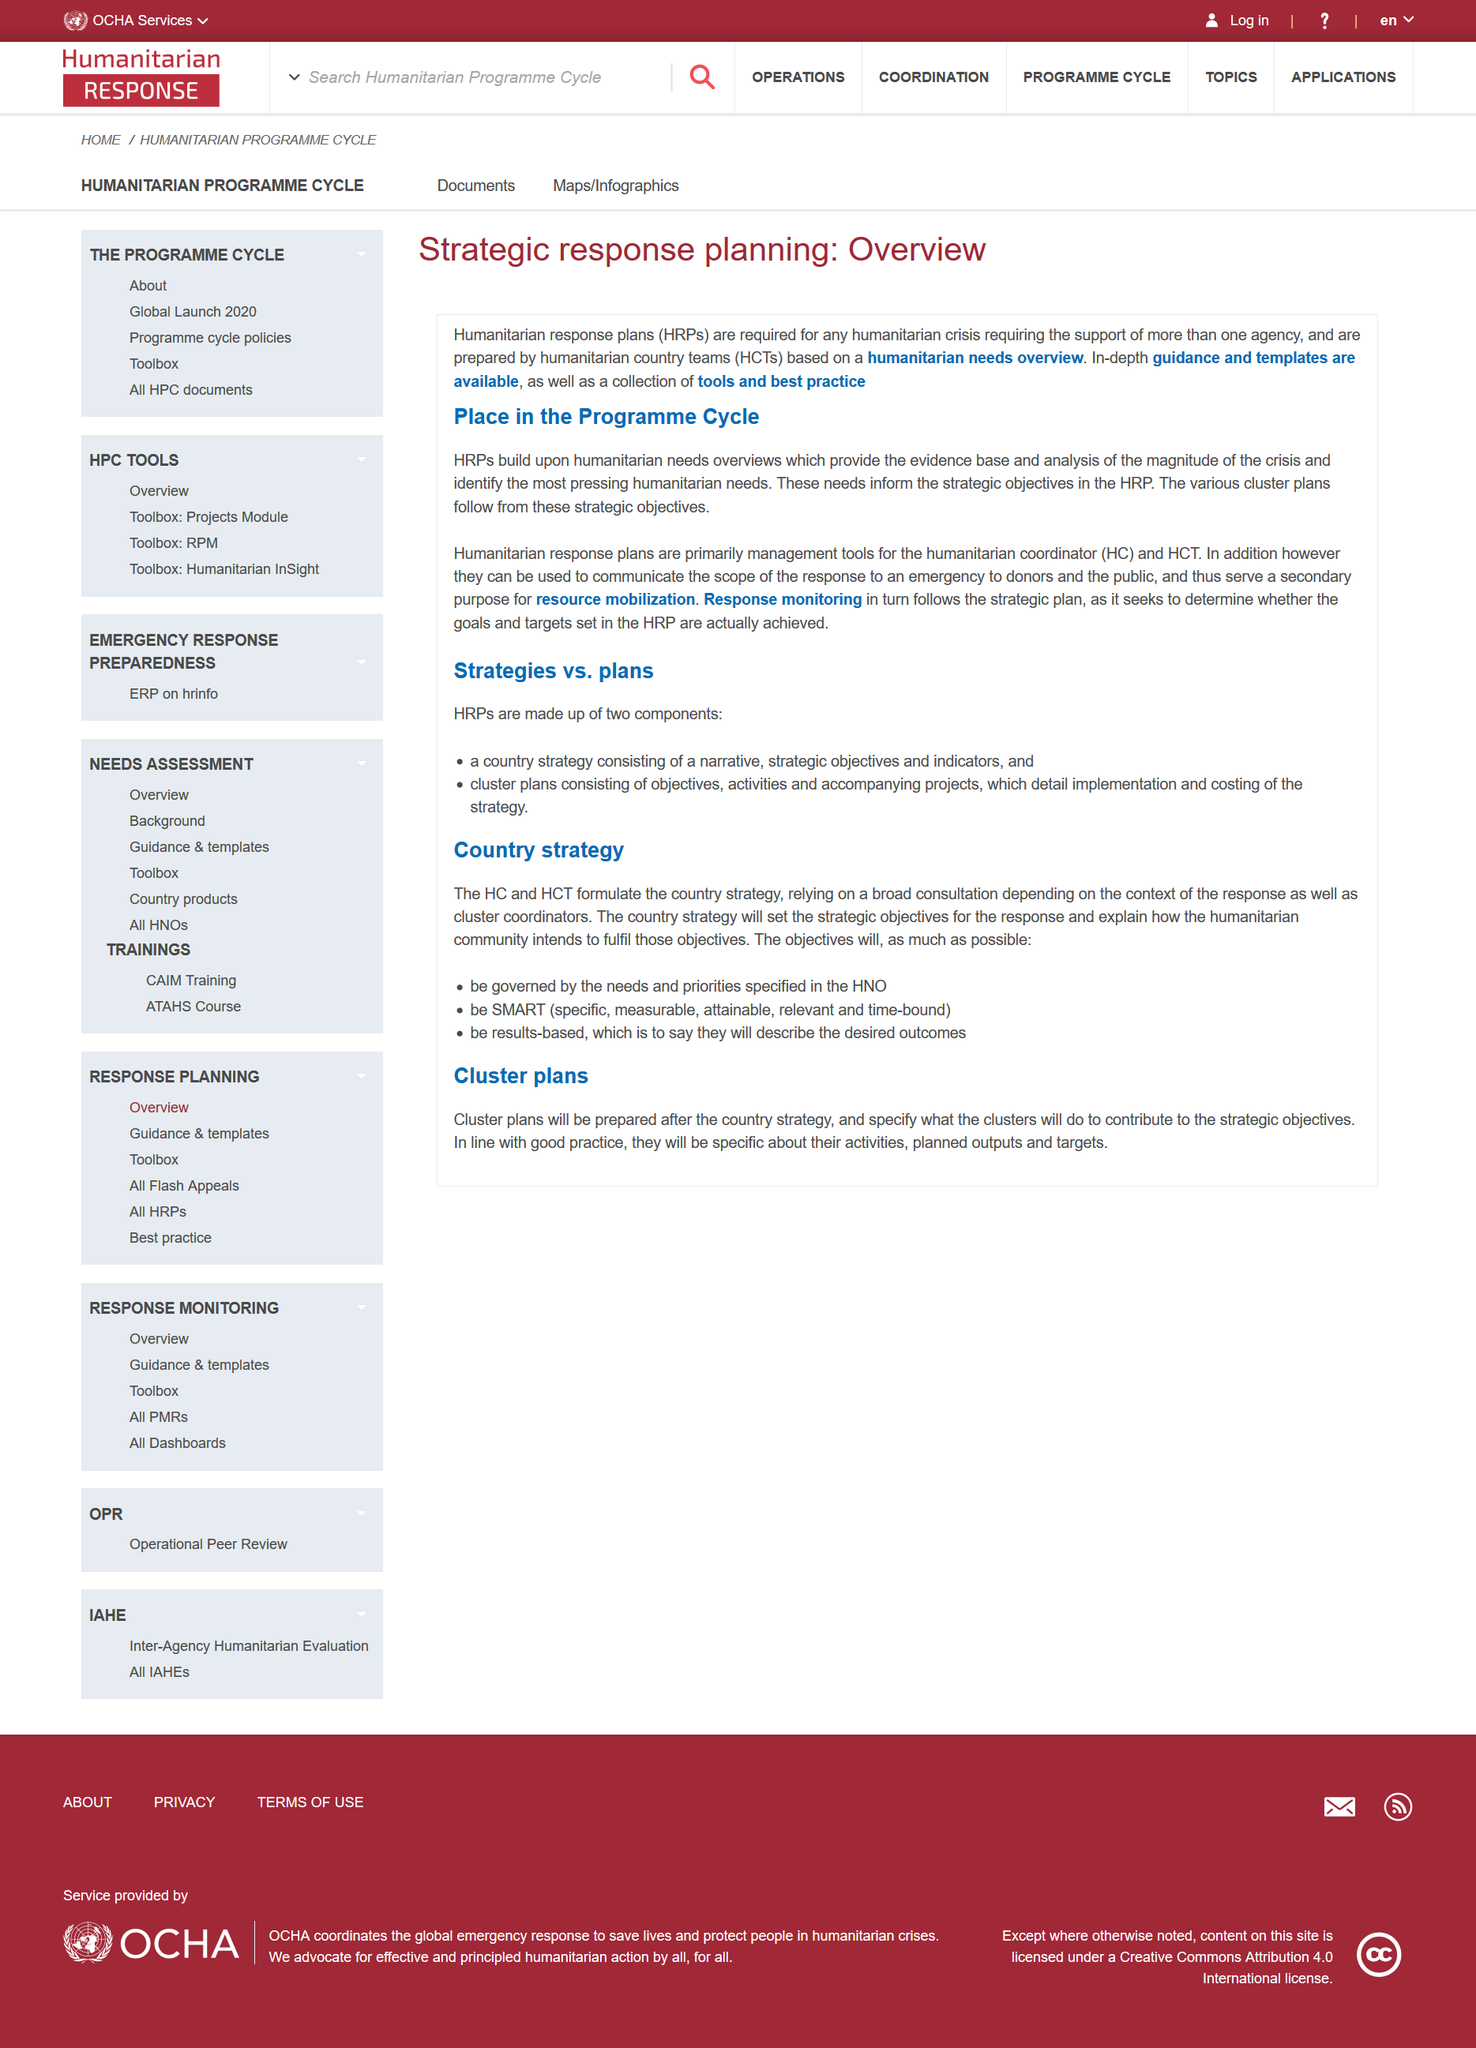Mention a couple of crucial points in this snapshot. In the context of humanitarian response plans, the acronyms HCT and HC have specific meanings. HCT stands for humanitarian country teams, which refer to the collective effort of humanitarian organizations operating in a particular country. HC, on the other hand, stands for humanitarian coordinator, which is an individual or group responsible for overseeing the implementation of humanitarian response plans in a given region or country. I declare that the objectives set by the country strategy shall consist of three key elements: they shall be governed by the specific needs and priorities outlined in the National Health Plan, they shall be SMART (Specific, Measurable, Attainable, Relevant, and Time-bound), and they shall be results-based, with a focus on achieving tangible and meaningful outcomes. The country strategy is formulated by the Human Capital Team (HCT) and the Head of Country Team (HC). The cluster plans are utilized to outline the actions that the clusters will undertake in order to contribute to the achievement of the strategic objectives. Humanitarian resource plans are not primarily designed to facilitate resource mobilization, but rather, their primary purpose is to support the implementation of humanitarian operations. 